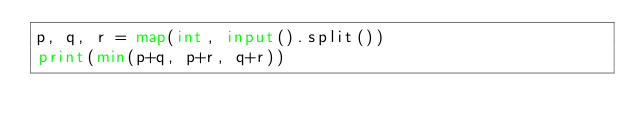Convert code to text. <code><loc_0><loc_0><loc_500><loc_500><_Python_>p, q, r = map(int, input().split())
print(min(p+q, p+r, q+r))</code> 